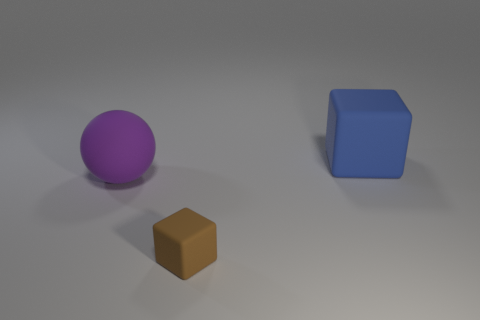What can you tell me about the materials and textures of the objects? The objects in the image seem to have different textures. The purple sphere has a matte finish, absorbing light and giving it a soft appearance. The blue cube seems to have a slightly reflective surface, indicating a smoother texture. As for the brown object, it appears more flat and also matte, much like the purple sphere, but without the same level of softness to its surface. 